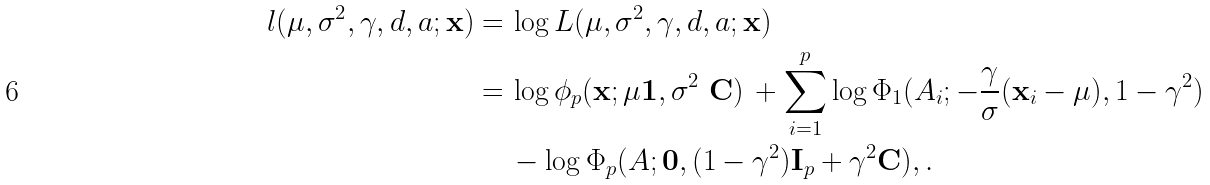Convert formula to latex. <formula><loc_0><loc_0><loc_500><loc_500>l ( \mu , \sigma ^ { 2 } , \gamma , d , a ; \mathbf x ) = \, & \log L ( \mu , \sigma ^ { 2 } , \gamma , d , a ; \mathbf x ) \\ = \, & \log \phi _ { p } ( \mathbf x ; \mu \mathbf 1 , \sigma ^ { 2 } \ \mathbf C ) \, + \sum _ { i = 1 } ^ { p } \log \Phi _ { 1 } ( A _ { i } ; - \frac { \gamma } { \sigma } ( \mathbf x _ { i } - \mu ) , 1 - \gamma ^ { 2 } ) \\ & - \log \Phi _ { p } ( A ; \mathbf 0 , ( 1 - \gamma ^ { 2 } ) \mathbf I _ { p } + \gamma ^ { 2 } \mathbf C ) , .</formula> 